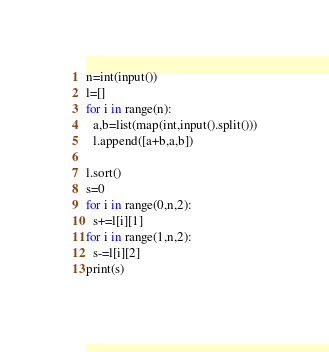<code> <loc_0><loc_0><loc_500><loc_500><_Python_>n=int(input())
l=[]
for i in range(n):
  a,b=list(map(int,input().split()))
  l.append([a+b,a,b])

l.sort()
s=0
for i in range(0,n,2):
  s+=l[i][1]
for i in range(1,n,2):
  s-=l[i][2]
print(s)</code> 